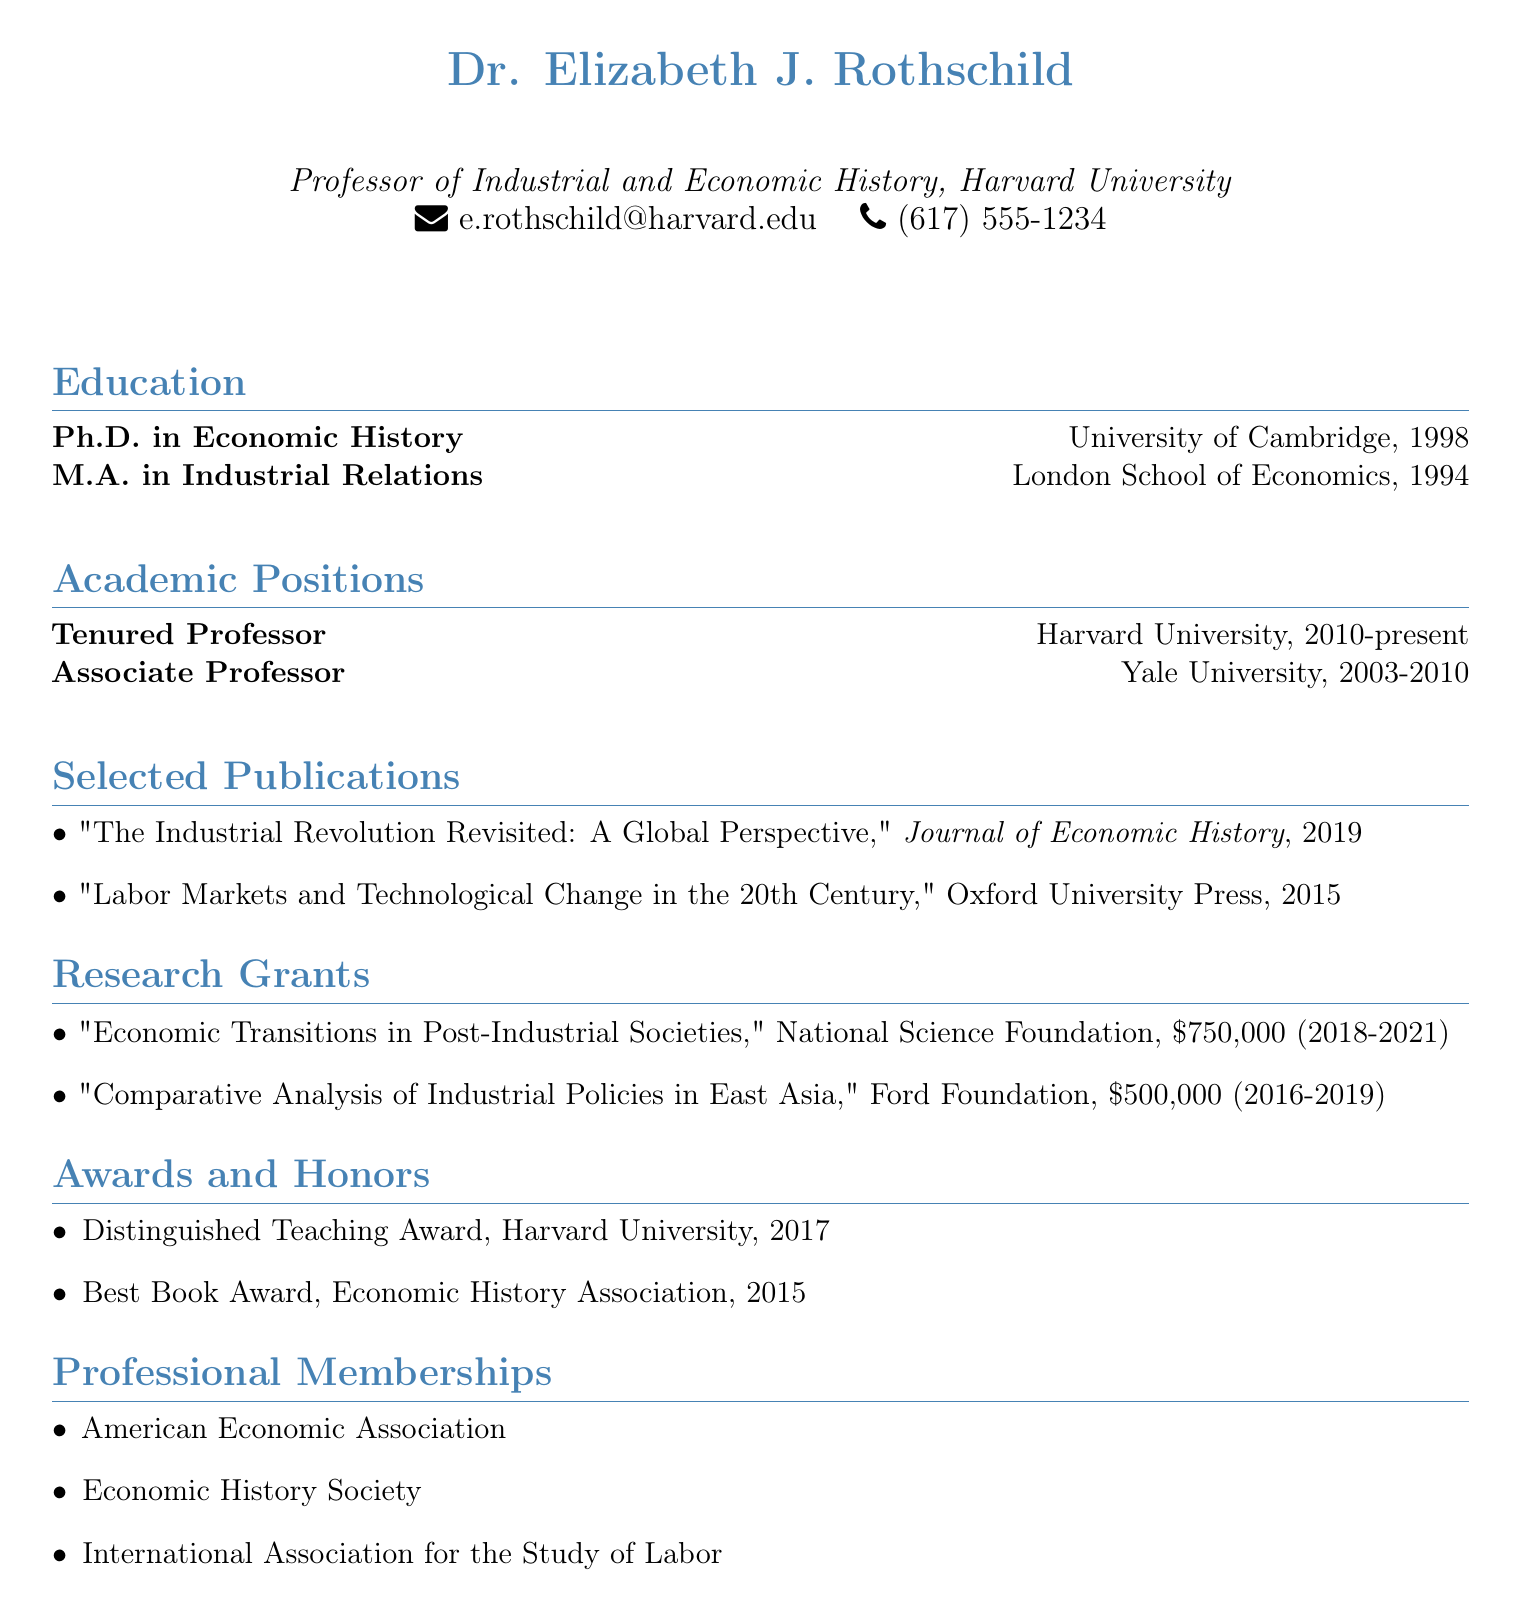What degree does Dr. Rothschild hold? The document clearly states Dr. Rothschild holds a Ph.D. in Economic History.
Answer: Ph.D. in Economic History Which university did Dr. Rothschild receive her Master’s degree from? The document indicates that Dr. Rothschild earned her M.A. at the London School of Economics.
Answer: London School of Economics How much funding did the National Science Foundation provide for the research grant? The document specifies that the National Science Foundation funded her research grant with $750,000.
Answer: $750,000 What was the title of Dr. Rothschild's book that won the Best Book Award? The document shows that "Labor Markets and Technological Change in the 20th Century" won the Best Book Award in 2015.
Answer: Labor Markets and Technological Change in the 20th Century What is the period of the awards received by Dr. Rothschild? The document reveals the awards are from 2015 and 2017, which suggests a two-year span for the relevant accolades.
Answer: 2015-2017 How many academic positions has Dr. Rothschild held? The document lists two academic positions, indicating her career trajectory through time.
Answer: 2 What is Dr. Rothschild’s current academic title? The resume states that she is a Tenured Professor at Harvard University.
Answer: Tenured Professor In which journal was her 2019 publication released? The document states that her publication "The Industrial Revolution Revisited: A Global Perspective" was featured in the Journal of Economic History.
Answer: Journal of Economic History 